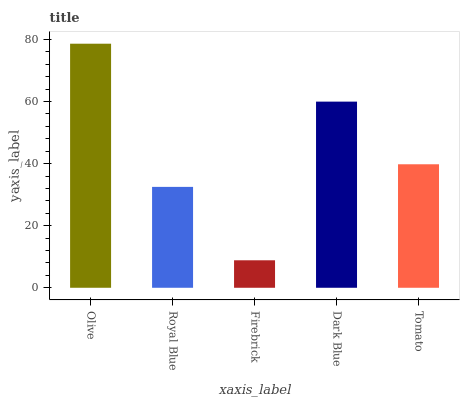Is Firebrick the minimum?
Answer yes or no. Yes. Is Olive the maximum?
Answer yes or no. Yes. Is Royal Blue the minimum?
Answer yes or no. No. Is Royal Blue the maximum?
Answer yes or no. No. Is Olive greater than Royal Blue?
Answer yes or no. Yes. Is Royal Blue less than Olive?
Answer yes or no. Yes. Is Royal Blue greater than Olive?
Answer yes or no. No. Is Olive less than Royal Blue?
Answer yes or no. No. Is Tomato the high median?
Answer yes or no. Yes. Is Tomato the low median?
Answer yes or no. Yes. Is Firebrick the high median?
Answer yes or no. No. Is Dark Blue the low median?
Answer yes or no. No. 